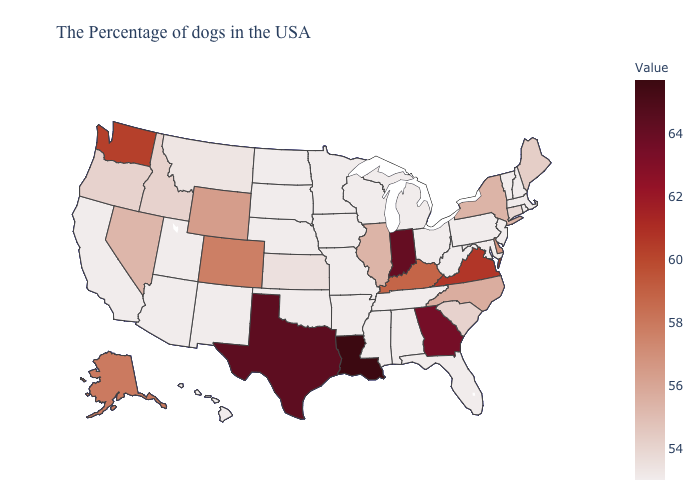Which states hav the highest value in the West?
Answer briefly. Washington. Among the states that border Idaho , which have the lowest value?
Keep it brief. Utah. Among the states that border New York , does Connecticut have the highest value?
Concise answer only. Yes. Among the states that border Tennessee , which have the lowest value?
Concise answer only. Alabama, Mississippi, Missouri, Arkansas. Among the states that border Colorado , which have the lowest value?
Short answer required. Nebraska, Oklahoma, New Mexico, Utah, Arizona. 